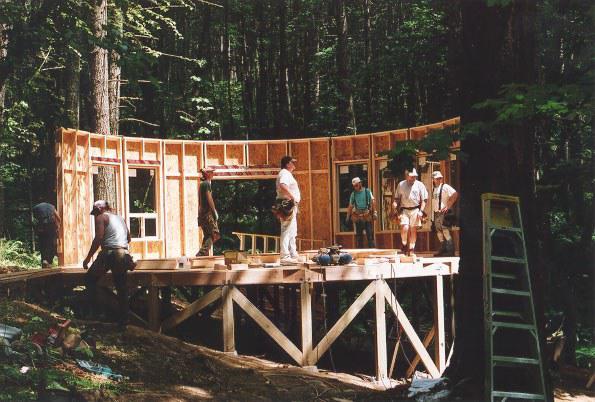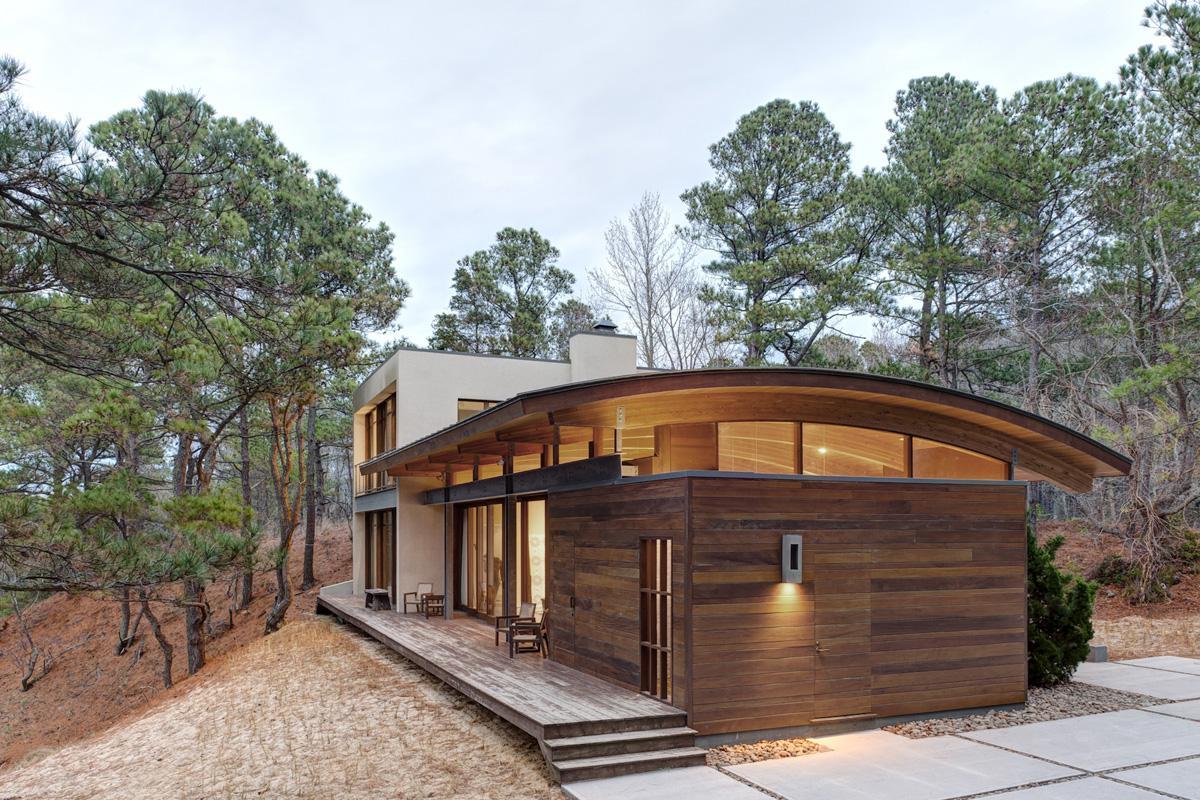The first image is the image on the left, the second image is the image on the right. Considering the images on both sides, is "A round house in one image has a metal roof with fan-shaped segments." valid? Answer yes or no. No. 